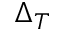<formula> <loc_0><loc_0><loc_500><loc_500>\Delta _ { T }</formula> 